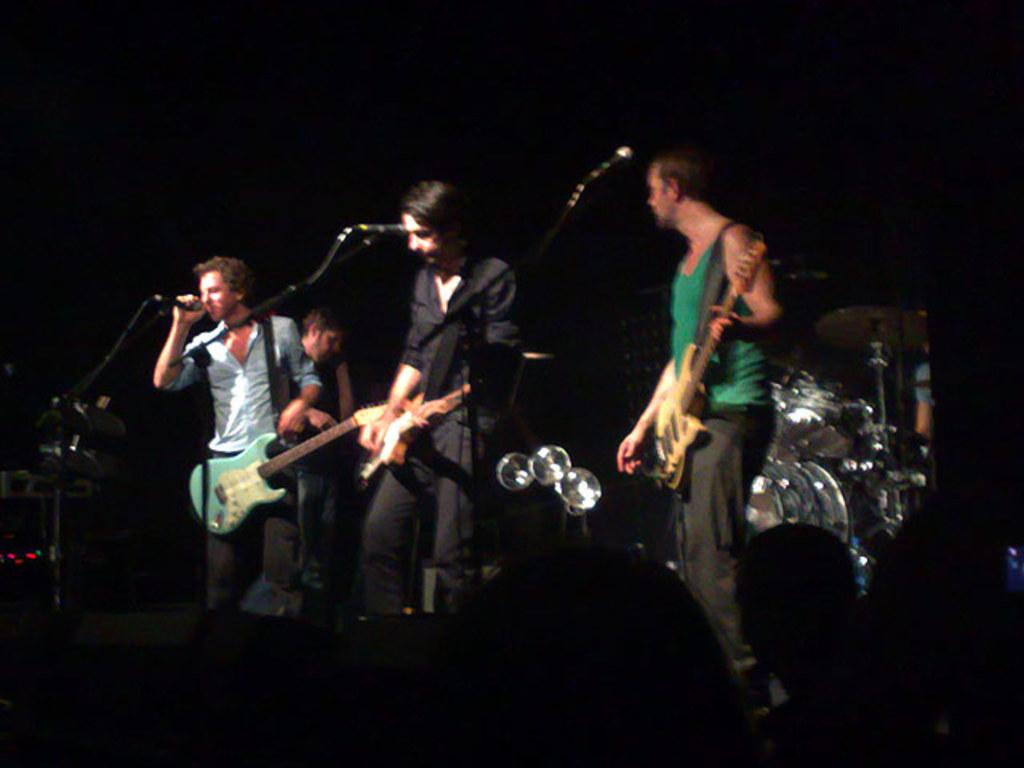How many people are playing instruments in the image? There are four people playing instruments in the image. What equipment is present for amplifying sound? There is a microphone and stand in the image. What type of musical instrument can be seen in the background? There is a drum set in the background of the image. What color is the background in the image? The background of the image is black. How many walls are visible in the image? There are no walls visible in the image; it features a group of people playing instruments against a black background. 